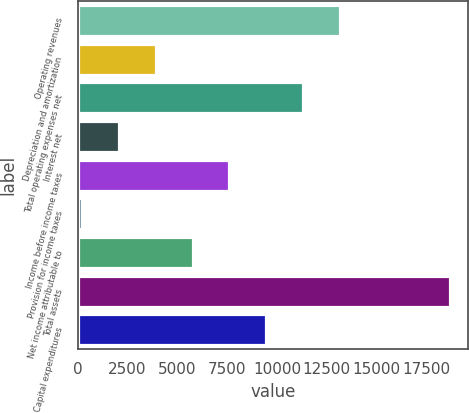<chart> <loc_0><loc_0><loc_500><loc_500><bar_chart><fcel>Operating revenues<fcel>Depreciation and amortization<fcel>Total operating expenses net<fcel>Interest net<fcel>Income before income taxes<fcel>Provision for income taxes<fcel>Net income attributable to<fcel>Total assets<fcel>Capital expenditures<nl><fcel>13143.2<fcel>3915.2<fcel>11297.6<fcel>2069.6<fcel>7606.4<fcel>224<fcel>5760.8<fcel>18680<fcel>9452<nl></chart> 